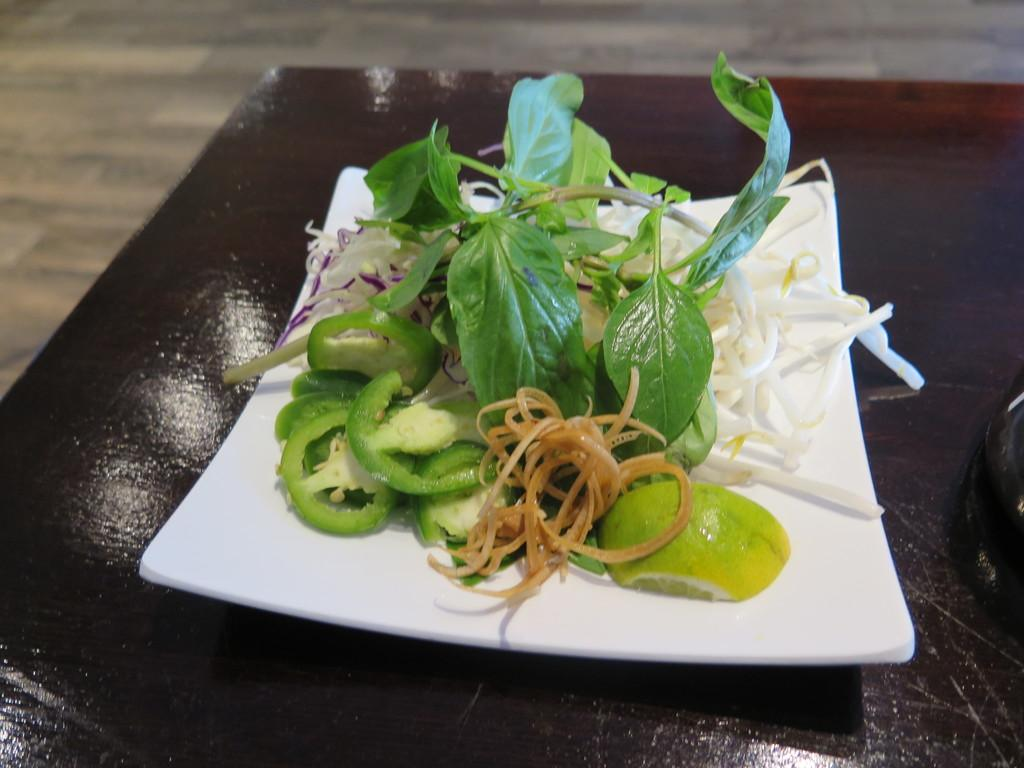What type of furniture is present in the image? There is a table in the image. What is on the table? There is a white, square-shaped plate on the table. What is on the plate? The plate contains vegetable salads. What can be seen below the table in the image? The floor is visible in the image. How are the tiles on the floor arranged? The floor has tiles arranged in a pattern. What type of skirt is hanging on the wall in the image? There is no skirt present in the image; it only features a table, a plate with vegetable salads, and a tiled floor. 